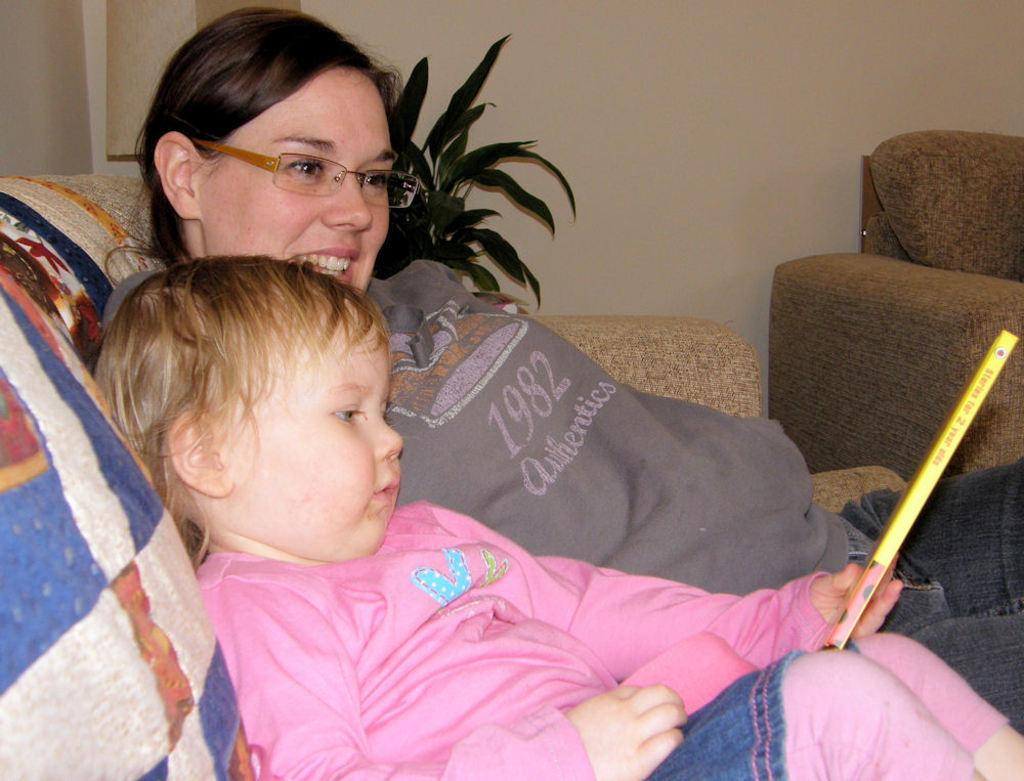Who is present in the image? There is a child and a woman in the image. What are they doing in the image? Both the child and woman are sitting on a sofa. What can be seen in the background of the image? There is a plant and a wall in the background of the image. What type of knot is the child tying in the image? There is no knot present in the image; the child is simply sitting on the sofa with the woman. 